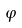Convert formula to latex. <formula><loc_0><loc_0><loc_500><loc_500>\varphi</formula> 